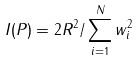<formula> <loc_0><loc_0><loc_500><loc_500>I ( P ) = 2 R ^ { 2 } / \sum ^ { N } _ { i = 1 } w _ { i } ^ { 2 }</formula> 